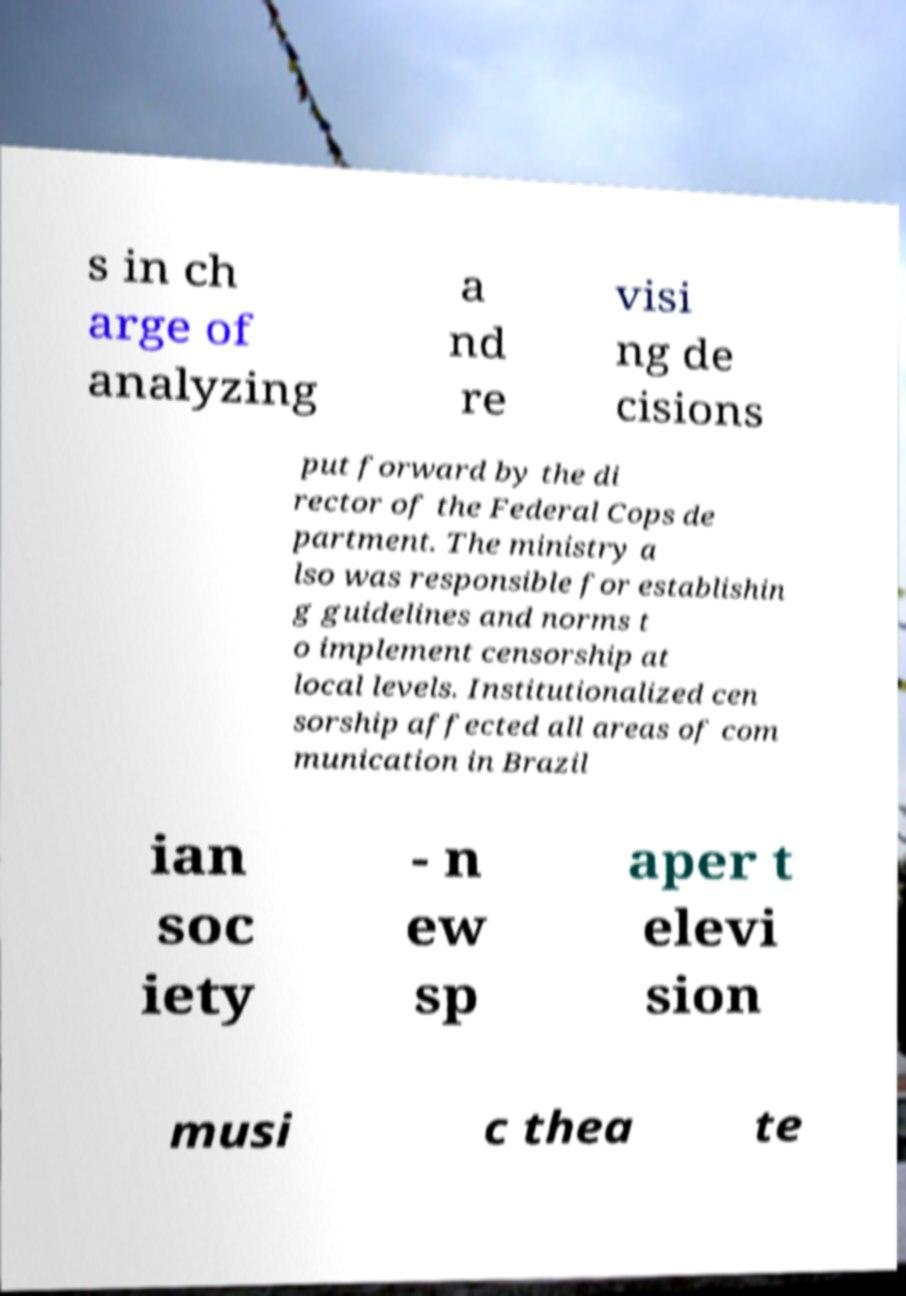Please identify and transcribe the text found in this image. s in ch arge of analyzing a nd re visi ng de cisions put forward by the di rector of the Federal Cops de partment. The ministry a lso was responsible for establishin g guidelines and norms t o implement censorship at local levels. Institutionalized cen sorship affected all areas of com munication in Brazil ian soc iety - n ew sp aper t elevi sion musi c thea te 